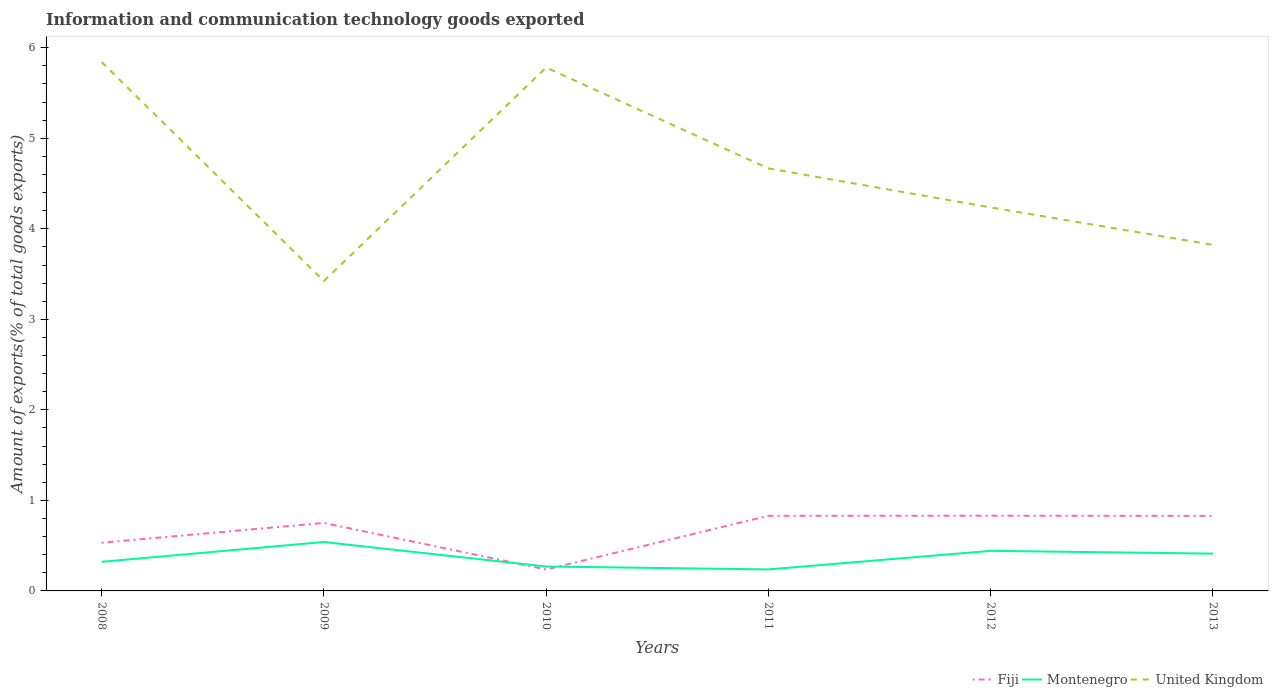How many different coloured lines are there?
Offer a very short reply. 3. Across all years, what is the maximum amount of goods exported in Montenegro?
Provide a succinct answer. 0.24. What is the total amount of goods exported in Fiji in the graph?
Keep it short and to the point. -0.08. What is the difference between the highest and the second highest amount of goods exported in Fiji?
Offer a terse response. 0.59. Is the amount of goods exported in United Kingdom strictly greater than the amount of goods exported in Montenegro over the years?
Ensure brevity in your answer.  No. How many lines are there?
Give a very brief answer. 3. What is the difference between two consecutive major ticks on the Y-axis?
Give a very brief answer. 1. How many legend labels are there?
Offer a terse response. 3. How are the legend labels stacked?
Your response must be concise. Horizontal. What is the title of the graph?
Provide a succinct answer. Information and communication technology goods exported. What is the label or title of the Y-axis?
Your answer should be very brief. Amount of exports(% of total goods exports). What is the Amount of exports(% of total goods exports) in Fiji in 2008?
Keep it short and to the point. 0.53. What is the Amount of exports(% of total goods exports) of Montenegro in 2008?
Offer a terse response. 0.32. What is the Amount of exports(% of total goods exports) in United Kingdom in 2008?
Provide a succinct answer. 5.84. What is the Amount of exports(% of total goods exports) in Fiji in 2009?
Provide a succinct answer. 0.75. What is the Amount of exports(% of total goods exports) in Montenegro in 2009?
Ensure brevity in your answer.  0.54. What is the Amount of exports(% of total goods exports) of United Kingdom in 2009?
Your answer should be very brief. 3.42. What is the Amount of exports(% of total goods exports) in Fiji in 2010?
Provide a short and direct response. 0.24. What is the Amount of exports(% of total goods exports) of Montenegro in 2010?
Provide a short and direct response. 0.27. What is the Amount of exports(% of total goods exports) in United Kingdom in 2010?
Offer a terse response. 5.78. What is the Amount of exports(% of total goods exports) of Fiji in 2011?
Provide a succinct answer. 0.83. What is the Amount of exports(% of total goods exports) in Montenegro in 2011?
Keep it short and to the point. 0.24. What is the Amount of exports(% of total goods exports) in United Kingdom in 2011?
Give a very brief answer. 4.67. What is the Amount of exports(% of total goods exports) in Fiji in 2012?
Provide a short and direct response. 0.83. What is the Amount of exports(% of total goods exports) in Montenegro in 2012?
Provide a short and direct response. 0.44. What is the Amount of exports(% of total goods exports) of United Kingdom in 2012?
Offer a terse response. 4.24. What is the Amount of exports(% of total goods exports) of Fiji in 2013?
Give a very brief answer. 0.83. What is the Amount of exports(% of total goods exports) of Montenegro in 2013?
Keep it short and to the point. 0.41. What is the Amount of exports(% of total goods exports) in United Kingdom in 2013?
Provide a short and direct response. 3.82. Across all years, what is the maximum Amount of exports(% of total goods exports) in Fiji?
Offer a very short reply. 0.83. Across all years, what is the maximum Amount of exports(% of total goods exports) of Montenegro?
Provide a succinct answer. 0.54. Across all years, what is the maximum Amount of exports(% of total goods exports) in United Kingdom?
Provide a succinct answer. 5.84. Across all years, what is the minimum Amount of exports(% of total goods exports) of Fiji?
Offer a terse response. 0.24. Across all years, what is the minimum Amount of exports(% of total goods exports) of Montenegro?
Ensure brevity in your answer.  0.24. Across all years, what is the minimum Amount of exports(% of total goods exports) of United Kingdom?
Make the answer very short. 3.42. What is the total Amount of exports(% of total goods exports) of Fiji in the graph?
Your answer should be compact. 4.01. What is the total Amount of exports(% of total goods exports) of Montenegro in the graph?
Provide a short and direct response. 2.22. What is the total Amount of exports(% of total goods exports) in United Kingdom in the graph?
Ensure brevity in your answer.  27.77. What is the difference between the Amount of exports(% of total goods exports) in Fiji in 2008 and that in 2009?
Offer a terse response. -0.22. What is the difference between the Amount of exports(% of total goods exports) in Montenegro in 2008 and that in 2009?
Provide a succinct answer. -0.22. What is the difference between the Amount of exports(% of total goods exports) of United Kingdom in 2008 and that in 2009?
Keep it short and to the point. 2.42. What is the difference between the Amount of exports(% of total goods exports) in Fiji in 2008 and that in 2010?
Provide a short and direct response. 0.3. What is the difference between the Amount of exports(% of total goods exports) in Montenegro in 2008 and that in 2010?
Ensure brevity in your answer.  0.05. What is the difference between the Amount of exports(% of total goods exports) in United Kingdom in 2008 and that in 2010?
Provide a short and direct response. 0.06. What is the difference between the Amount of exports(% of total goods exports) in Fiji in 2008 and that in 2011?
Keep it short and to the point. -0.3. What is the difference between the Amount of exports(% of total goods exports) in Montenegro in 2008 and that in 2011?
Make the answer very short. 0.08. What is the difference between the Amount of exports(% of total goods exports) of United Kingdom in 2008 and that in 2011?
Your response must be concise. 1.18. What is the difference between the Amount of exports(% of total goods exports) in Fiji in 2008 and that in 2012?
Offer a very short reply. -0.3. What is the difference between the Amount of exports(% of total goods exports) in Montenegro in 2008 and that in 2012?
Make the answer very short. -0.12. What is the difference between the Amount of exports(% of total goods exports) in United Kingdom in 2008 and that in 2012?
Provide a short and direct response. 1.61. What is the difference between the Amount of exports(% of total goods exports) in Fiji in 2008 and that in 2013?
Your response must be concise. -0.3. What is the difference between the Amount of exports(% of total goods exports) in Montenegro in 2008 and that in 2013?
Provide a short and direct response. -0.09. What is the difference between the Amount of exports(% of total goods exports) of United Kingdom in 2008 and that in 2013?
Make the answer very short. 2.02. What is the difference between the Amount of exports(% of total goods exports) of Fiji in 2009 and that in 2010?
Offer a terse response. 0.51. What is the difference between the Amount of exports(% of total goods exports) in Montenegro in 2009 and that in 2010?
Give a very brief answer. 0.27. What is the difference between the Amount of exports(% of total goods exports) of United Kingdom in 2009 and that in 2010?
Provide a short and direct response. -2.36. What is the difference between the Amount of exports(% of total goods exports) in Fiji in 2009 and that in 2011?
Provide a succinct answer. -0.08. What is the difference between the Amount of exports(% of total goods exports) of Montenegro in 2009 and that in 2011?
Provide a succinct answer. 0.3. What is the difference between the Amount of exports(% of total goods exports) of United Kingdom in 2009 and that in 2011?
Offer a very short reply. -1.24. What is the difference between the Amount of exports(% of total goods exports) in Fiji in 2009 and that in 2012?
Keep it short and to the point. -0.08. What is the difference between the Amount of exports(% of total goods exports) of Montenegro in 2009 and that in 2012?
Your answer should be very brief. 0.1. What is the difference between the Amount of exports(% of total goods exports) of United Kingdom in 2009 and that in 2012?
Provide a succinct answer. -0.81. What is the difference between the Amount of exports(% of total goods exports) in Fiji in 2009 and that in 2013?
Your answer should be very brief. -0.08. What is the difference between the Amount of exports(% of total goods exports) of Montenegro in 2009 and that in 2013?
Make the answer very short. 0.13. What is the difference between the Amount of exports(% of total goods exports) of United Kingdom in 2009 and that in 2013?
Make the answer very short. -0.4. What is the difference between the Amount of exports(% of total goods exports) of Fiji in 2010 and that in 2011?
Offer a terse response. -0.59. What is the difference between the Amount of exports(% of total goods exports) in Montenegro in 2010 and that in 2011?
Offer a very short reply. 0.03. What is the difference between the Amount of exports(% of total goods exports) in United Kingdom in 2010 and that in 2011?
Offer a very short reply. 1.11. What is the difference between the Amount of exports(% of total goods exports) of Fiji in 2010 and that in 2012?
Your response must be concise. -0.59. What is the difference between the Amount of exports(% of total goods exports) in Montenegro in 2010 and that in 2012?
Provide a succinct answer. -0.17. What is the difference between the Amount of exports(% of total goods exports) of United Kingdom in 2010 and that in 2012?
Your answer should be compact. 1.55. What is the difference between the Amount of exports(% of total goods exports) of Fiji in 2010 and that in 2013?
Keep it short and to the point. -0.59. What is the difference between the Amount of exports(% of total goods exports) in Montenegro in 2010 and that in 2013?
Offer a terse response. -0.14. What is the difference between the Amount of exports(% of total goods exports) of United Kingdom in 2010 and that in 2013?
Offer a terse response. 1.96. What is the difference between the Amount of exports(% of total goods exports) in Fiji in 2011 and that in 2012?
Provide a short and direct response. -0. What is the difference between the Amount of exports(% of total goods exports) in Montenegro in 2011 and that in 2012?
Give a very brief answer. -0.21. What is the difference between the Amount of exports(% of total goods exports) in United Kingdom in 2011 and that in 2012?
Provide a succinct answer. 0.43. What is the difference between the Amount of exports(% of total goods exports) of Fiji in 2011 and that in 2013?
Make the answer very short. 0. What is the difference between the Amount of exports(% of total goods exports) in Montenegro in 2011 and that in 2013?
Keep it short and to the point. -0.17. What is the difference between the Amount of exports(% of total goods exports) of United Kingdom in 2011 and that in 2013?
Offer a very short reply. 0.84. What is the difference between the Amount of exports(% of total goods exports) in Fiji in 2012 and that in 2013?
Your answer should be compact. 0. What is the difference between the Amount of exports(% of total goods exports) of Montenegro in 2012 and that in 2013?
Give a very brief answer. 0.03. What is the difference between the Amount of exports(% of total goods exports) in United Kingdom in 2012 and that in 2013?
Make the answer very short. 0.41. What is the difference between the Amount of exports(% of total goods exports) in Fiji in 2008 and the Amount of exports(% of total goods exports) in Montenegro in 2009?
Keep it short and to the point. -0.01. What is the difference between the Amount of exports(% of total goods exports) of Fiji in 2008 and the Amount of exports(% of total goods exports) of United Kingdom in 2009?
Your answer should be compact. -2.89. What is the difference between the Amount of exports(% of total goods exports) in Montenegro in 2008 and the Amount of exports(% of total goods exports) in United Kingdom in 2009?
Your response must be concise. -3.1. What is the difference between the Amount of exports(% of total goods exports) of Fiji in 2008 and the Amount of exports(% of total goods exports) of Montenegro in 2010?
Keep it short and to the point. 0.26. What is the difference between the Amount of exports(% of total goods exports) of Fiji in 2008 and the Amount of exports(% of total goods exports) of United Kingdom in 2010?
Make the answer very short. -5.25. What is the difference between the Amount of exports(% of total goods exports) in Montenegro in 2008 and the Amount of exports(% of total goods exports) in United Kingdom in 2010?
Offer a very short reply. -5.46. What is the difference between the Amount of exports(% of total goods exports) in Fiji in 2008 and the Amount of exports(% of total goods exports) in Montenegro in 2011?
Provide a short and direct response. 0.29. What is the difference between the Amount of exports(% of total goods exports) of Fiji in 2008 and the Amount of exports(% of total goods exports) of United Kingdom in 2011?
Give a very brief answer. -4.13. What is the difference between the Amount of exports(% of total goods exports) in Montenegro in 2008 and the Amount of exports(% of total goods exports) in United Kingdom in 2011?
Offer a terse response. -4.35. What is the difference between the Amount of exports(% of total goods exports) of Fiji in 2008 and the Amount of exports(% of total goods exports) of Montenegro in 2012?
Ensure brevity in your answer.  0.09. What is the difference between the Amount of exports(% of total goods exports) in Fiji in 2008 and the Amount of exports(% of total goods exports) in United Kingdom in 2012?
Make the answer very short. -3.7. What is the difference between the Amount of exports(% of total goods exports) in Montenegro in 2008 and the Amount of exports(% of total goods exports) in United Kingdom in 2012?
Give a very brief answer. -3.91. What is the difference between the Amount of exports(% of total goods exports) of Fiji in 2008 and the Amount of exports(% of total goods exports) of Montenegro in 2013?
Make the answer very short. 0.12. What is the difference between the Amount of exports(% of total goods exports) of Fiji in 2008 and the Amount of exports(% of total goods exports) of United Kingdom in 2013?
Your response must be concise. -3.29. What is the difference between the Amount of exports(% of total goods exports) of Montenegro in 2008 and the Amount of exports(% of total goods exports) of United Kingdom in 2013?
Provide a short and direct response. -3.5. What is the difference between the Amount of exports(% of total goods exports) in Fiji in 2009 and the Amount of exports(% of total goods exports) in Montenegro in 2010?
Your answer should be compact. 0.48. What is the difference between the Amount of exports(% of total goods exports) in Fiji in 2009 and the Amount of exports(% of total goods exports) in United Kingdom in 2010?
Your response must be concise. -5.03. What is the difference between the Amount of exports(% of total goods exports) of Montenegro in 2009 and the Amount of exports(% of total goods exports) of United Kingdom in 2010?
Provide a succinct answer. -5.24. What is the difference between the Amount of exports(% of total goods exports) of Fiji in 2009 and the Amount of exports(% of total goods exports) of Montenegro in 2011?
Your answer should be compact. 0.51. What is the difference between the Amount of exports(% of total goods exports) in Fiji in 2009 and the Amount of exports(% of total goods exports) in United Kingdom in 2011?
Keep it short and to the point. -3.92. What is the difference between the Amount of exports(% of total goods exports) of Montenegro in 2009 and the Amount of exports(% of total goods exports) of United Kingdom in 2011?
Provide a succinct answer. -4.13. What is the difference between the Amount of exports(% of total goods exports) in Fiji in 2009 and the Amount of exports(% of total goods exports) in Montenegro in 2012?
Make the answer very short. 0.31. What is the difference between the Amount of exports(% of total goods exports) in Fiji in 2009 and the Amount of exports(% of total goods exports) in United Kingdom in 2012?
Ensure brevity in your answer.  -3.49. What is the difference between the Amount of exports(% of total goods exports) of Montenegro in 2009 and the Amount of exports(% of total goods exports) of United Kingdom in 2012?
Ensure brevity in your answer.  -3.7. What is the difference between the Amount of exports(% of total goods exports) of Fiji in 2009 and the Amount of exports(% of total goods exports) of Montenegro in 2013?
Your answer should be very brief. 0.34. What is the difference between the Amount of exports(% of total goods exports) of Fiji in 2009 and the Amount of exports(% of total goods exports) of United Kingdom in 2013?
Keep it short and to the point. -3.07. What is the difference between the Amount of exports(% of total goods exports) in Montenegro in 2009 and the Amount of exports(% of total goods exports) in United Kingdom in 2013?
Make the answer very short. -3.28. What is the difference between the Amount of exports(% of total goods exports) of Fiji in 2010 and the Amount of exports(% of total goods exports) of Montenegro in 2011?
Your answer should be very brief. -0. What is the difference between the Amount of exports(% of total goods exports) of Fiji in 2010 and the Amount of exports(% of total goods exports) of United Kingdom in 2011?
Keep it short and to the point. -4.43. What is the difference between the Amount of exports(% of total goods exports) of Montenegro in 2010 and the Amount of exports(% of total goods exports) of United Kingdom in 2011?
Give a very brief answer. -4.4. What is the difference between the Amount of exports(% of total goods exports) of Fiji in 2010 and the Amount of exports(% of total goods exports) of Montenegro in 2012?
Your answer should be very brief. -0.21. What is the difference between the Amount of exports(% of total goods exports) in Fiji in 2010 and the Amount of exports(% of total goods exports) in United Kingdom in 2012?
Your answer should be very brief. -4. What is the difference between the Amount of exports(% of total goods exports) in Montenegro in 2010 and the Amount of exports(% of total goods exports) in United Kingdom in 2012?
Provide a succinct answer. -3.97. What is the difference between the Amount of exports(% of total goods exports) of Fiji in 2010 and the Amount of exports(% of total goods exports) of Montenegro in 2013?
Provide a succinct answer. -0.18. What is the difference between the Amount of exports(% of total goods exports) of Fiji in 2010 and the Amount of exports(% of total goods exports) of United Kingdom in 2013?
Ensure brevity in your answer.  -3.59. What is the difference between the Amount of exports(% of total goods exports) of Montenegro in 2010 and the Amount of exports(% of total goods exports) of United Kingdom in 2013?
Make the answer very short. -3.55. What is the difference between the Amount of exports(% of total goods exports) of Fiji in 2011 and the Amount of exports(% of total goods exports) of Montenegro in 2012?
Offer a very short reply. 0.39. What is the difference between the Amount of exports(% of total goods exports) of Fiji in 2011 and the Amount of exports(% of total goods exports) of United Kingdom in 2012?
Your answer should be very brief. -3.41. What is the difference between the Amount of exports(% of total goods exports) of Montenegro in 2011 and the Amount of exports(% of total goods exports) of United Kingdom in 2012?
Provide a short and direct response. -4. What is the difference between the Amount of exports(% of total goods exports) in Fiji in 2011 and the Amount of exports(% of total goods exports) in Montenegro in 2013?
Keep it short and to the point. 0.42. What is the difference between the Amount of exports(% of total goods exports) in Fiji in 2011 and the Amount of exports(% of total goods exports) in United Kingdom in 2013?
Provide a short and direct response. -2.99. What is the difference between the Amount of exports(% of total goods exports) in Montenegro in 2011 and the Amount of exports(% of total goods exports) in United Kingdom in 2013?
Provide a succinct answer. -3.59. What is the difference between the Amount of exports(% of total goods exports) of Fiji in 2012 and the Amount of exports(% of total goods exports) of Montenegro in 2013?
Ensure brevity in your answer.  0.42. What is the difference between the Amount of exports(% of total goods exports) in Fiji in 2012 and the Amount of exports(% of total goods exports) in United Kingdom in 2013?
Provide a succinct answer. -2.99. What is the difference between the Amount of exports(% of total goods exports) of Montenegro in 2012 and the Amount of exports(% of total goods exports) of United Kingdom in 2013?
Your response must be concise. -3.38. What is the average Amount of exports(% of total goods exports) in Fiji per year?
Keep it short and to the point. 0.67. What is the average Amount of exports(% of total goods exports) of Montenegro per year?
Provide a short and direct response. 0.37. What is the average Amount of exports(% of total goods exports) in United Kingdom per year?
Offer a terse response. 4.63. In the year 2008, what is the difference between the Amount of exports(% of total goods exports) in Fiji and Amount of exports(% of total goods exports) in Montenegro?
Your answer should be compact. 0.21. In the year 2008, what is the difference between the Amount of exports(% of total goods exports) in Fiji and Amount of exports(% of total goods exports) in United Kingdom?
Make the answer very short. -5.31. In the year 2008, what is the difference between the Amount of exports(% of total goods exports) of Montenegro and Amount of exports(% of total goods exports) of United Kingdom?
Ensure brevity in your answer.  -5.52. In the year 2009, what is the difference between the Amount of exports(% of total goods exports) in Fiji and Amount of exports(% of total goods exports) in Montenegro?
Provide a succinct answer. 0.21. In the year 2009, what is the difference between the Amount of exports(% of total goods exports) of Fiji and Amount of exports(% of total goods exports) of United Kingdom?
Provide a succinct answer. -2.67. In the year 2009, what is the difference between the Amount of exports(% of total goods exports) in Montenegro and Amount of exports(% of total goods exports) in United Kingdom?
Provide a short and direct response. -2.88. In the year 2010, what is the difference between the Amount of exports(% of total goods exports) of Fiji and Amount of exports(% of total goods exports) of Montenegro?
Provide a succinct answer. -0.03. In the year 2010, what is the difference between the Amount of exports(% of total goods exports) in Fiji and Amount of exports(% of total goods exports) in United Kingdom?
Your answer should be very brief. -5.55. In the year 2010, what is the difference between the Amount of exports(% of total goods exports) of Montenegro and Amount of exports(% of total goods exports) of United Kingdom?
Ensure brevity in your answer.  -5.51. In the year 2011, what is the difference between the Amount of exports(% of total goods exports) of Fiji and Amount of exports(% of total goods exports) of Montenegro?
Keep it short and to the point. 0.59. In the year 2011, what is the difference between the Amount of exports(% of total goods exports) in Fiji and Amount of exports(% of total goods exports) in United Kingdom?
Make the answer very short. -3.84. In the year 2011, what is the difference between the Amount of exports(% of total goods exports) of Montenegro and Amount of exports(% of total goods exports) of United Kingdom?
Make the answer very short. -4.43. In the year 2012, what is the difference between the Amount of exports(% of total goods exports) of Fiji and Amount of exports(% of total goods exports) of Montenegro?
Make the answer very short. 0.39. In the year 2012, what is the difference between the Amount of exports(% of total goods exports) in Fiji and Amount of exports(% of total goods exports) in United Kingdom?
Ensure brevity in your answer.  -3.41. In the year 2012, what is the difference between the Amount of exports(% of total goods exports) in Montenegro and Amount of exports(% of total goods exports) in United Kingdom?
Your answer should be very brief. -3.79. In the year 2013, what is the difference between the Amount of exports(% of total goods exports) of Fiji and Amount of exports(% of total goods exports) of Montenegro?
Provide a succinct answer. 0.42. In the year 2013, what is the difference between the Amount of exports(% of total goods exports) of Fiji and Amount of exports(% of total goods exports) of United Kingdom?
Keep it short and to the point. -2.99. In the year 2013, what is the difference between the Amount of exports(% of total goods exports) of Montenegro and Amount of exports(% of total goods exports) of United Kingdom?
Your answer should be very brief. -3.41. What is the ratio of the Amount of exports(% of total goods exports) of Fiji in 2008 to that in 2009?
Provide a short and direct response. 0.71. What is the ratio of the Amount of exports(% of total goods exports) of Montenegro in 2008 to that in 2009?
Offer a very short reply. 0.6. What is the ratio of the Amount of exports(% of total goods exports) in United Kingdom in 2008 to that in 2009?
Keep it short and to the point. 1.71. What is the ratio of the Amount of exports(% of total goods exports) of Fiji in 2008 to that in 2010?
Offer a terse response. 2.25. What is the ratio of the Amount of exports(% of total goods exports) in Montenegro in 2008 to that in 2010?
Your answer should be compact. 1.19. What is the ratio of the Amount of exports(% of total goods exports) in United Kingdom in 2008 to that in 2010?
Ensure brevity in your answer.  1.01. What is the ratio of the Amount of exports(% of total goods exports) of Fiji in 2008 to that in 2011?
Give a very brief answer. 0.64. What is the ratio of the Amount of exports(% of total goods exports) in Montenegro in 2008 to that in 2011?
Your answer should be very brief. 1.35. What is the ratio of the Amount of exports(% of total goods exports) in United Kingdom in 2008 to that in 2011?
Offer a very short reply. 1.25. What is the ratio of the Amount of exports(% of total goods exports) of Fiji in 2008 to that in 2012?
Your answer should be very brief. 0.64. What is the ratio of the Amount of exports(% of total goods exports) in Montenegro in 2008 to that in 2012?
Offer a very short reply. 0.73. What is the ratio of the Amount of exports(% of total goods exports) in United Kingdom in 2008 to that in 2012?
Offer a terse response. 1.38. What is the ratio of the Amount of exports(% of total goods exports) of Fiji in 2008 to that in 2013?
Make the answer very short. 0.64. What is the ratio of the Amount of exports(% of total goods exports) of Montenegro in 2008 to that in 2013?
Provide a succinct answer. 0.78. What is the ratio of the Amount of exports(% of total goods exports) in United Kingdom in 2008 to that in 2013?
Provide a succinct answer. 1.53. What is the ratio of the Amount of exports(% of total goods exports) in Fiji in 2009 to that in 2010?
Offer a terse response. 3.17. What is the ratio of the Amount of exports(% of total goods exports) of Montenegro in 2009 to that in 2010?
Your response must be concise. 2.01. What is the ratio of the Amount of exports(% of total goods exports) of United Kingdom in 2009 to that in 2010?
Ensure brevity in your answer.  0.59. What is the ratio of the Amount of exports(% of total goods exports) of Fiji in 2009 to that in 2011?
Offer a terse response. 0.91. What is the ratio of the Amount of exports(% of total goods exports) in Montenegro in 2009 to that in 2011?
Your answer should be very brief. 2.28. What is the ratio of the Amount of exports(% of total goods exports) in United Kingdom in 2009 to that in 2011?
Give a very brief answer. 0.73. What is the ratio of the Amount of exports(% of total goods exports) in Fiji in 2009 to that in 2012?
Provide a succinct answer. 0.9. What is the ratio of the Amount of exports(% of total goods exports) in Montenegro in 2009 to that in 2012?
Your response must be concise. 1.22. What is the ratio of the Amount of exports(% of total goods exports) of United Kingdom in 2009 to that in 2012?
Your answer should be compact. 0.81. What is the ratio of the Amount of exports(% of total goods exports) in Fiji in 2009 to that in 2013?
Ensure brevity in your answer.  0.91. What is the ratio of the Amount of exports(% of total goods exports) in Montenegro in 2009 to that in 2013?
Make the answer very short. 1.31. What is the ratio of the Amount of exports(% of total goods exports) in United Kingdom in 2009 to that in 2013?
Provide a succinct answer. 0.9. What is the ratio of the Amount of exports(% of total goods exports) in Fiji in 2010 to that in 2011?
Make the answer very short. 0.29. What is the ratio of the Amount of exports(% of total goods exports) of Montenegro in 2010 to that in 2011?
Offer a very short reply. 1.13. What is the ratio of the Amount of exports(% of total goods exports) of United Kingdom in 2010 to that in 2011?
Your response must be concise. 1.24. What is the ratio of the Amount of exports(% of total goods exports) of Fiji in 2010 to that in 2012?
Offer a very short reply. 0.28. What is the ratio of the Amount of exports(% of total goods exports) of Montenegro in 2010 to that in 2012?
Offer a terse response. 0.61. What is the ratio of the Amount of exports(% of total goods exports) of United Kingdom in 2010 to that in 2012?
Provide a succinct answer. 1.36. What is the ratio of the Amount of exports(% of total goods exports) of Fiji in 2010 to that in 2013?
Ensure brevity in your answer.  0.29. What is the ratio of the Amount of exports(% of total goods exports) of Montenegro in 2010 to that in 2013?
Provide a succinct answer. 0.65. What is the ratio of the Amount of exports(% of total goods exports) of United Kingdom in 2010 to that in 2013?
Ensure brevity in your answer.  1.51. What is the ratio of the Amount of exports(% of total goods exports) of Montenegro in 2011 to that in 2012?
Keep it short and to the point. 0.54. What is the ratio of the Amount of exports(% of total goods exports) in United Kingdom in 2011 to that in 2012?
Your response must be concise. 1.1. What is the ratio of the Amount of exports(% of total goods exports) in Fiji in 2011 to that in 2013?
Keep it short and to the point. 1. What is the ratio of the Amount of exports(% of total goods exports) of Montenegro in 2011 to that in 2013?
Offer a terse response. 0.58. What is the ratio of the Amount of exports(% of total goods exports) in United Kingdom in 2011 to that in 2013?
Provide a short and direct response. 1.22. What is the ratio of the Amount of exports(% of total goods exports) in Fiji in 2012 to that in 2013?
Your answer should be compact. 1. What is the ratio of the Amount of exports(% of total goods exports) in Montenegro in 2012 to that in 2013?
Offer a very short reply. 1.07. What is the ratio of the Amount of exports(% of total goods exports) in United Kingdom in 2012 to that in 2013?
Ensure brevity in your answer.  1.11. What is the difference between the highest and the second highest Amount of exports(% of total goods exports) in Fiji?
Your answer should be compact. 0. What is the difference between the highest and the second highest Amount of exports(% of total goods exports) in Montenegro?
Your answer should be very brief. 0.1. What is the difference between the highest and the second highest Amount of exports(% of total goods exports) in United Kingdom?
Your answer should be compact. 0.06. What is the difference between the highest and the lowest Amount of exports(% of total goods exports) in Fiji?
Keep it short and to the point. 0.59. What is the difference between the highest and the lowest Amount of exports(% of total goods exports) of Montenegro?
Ensure brevity in your answer.  0.3. What is the difference between the highest and the lowest Amount of exports(% of total goods exports) of United Kingdom?
Offer a very short reply. 2.42. 